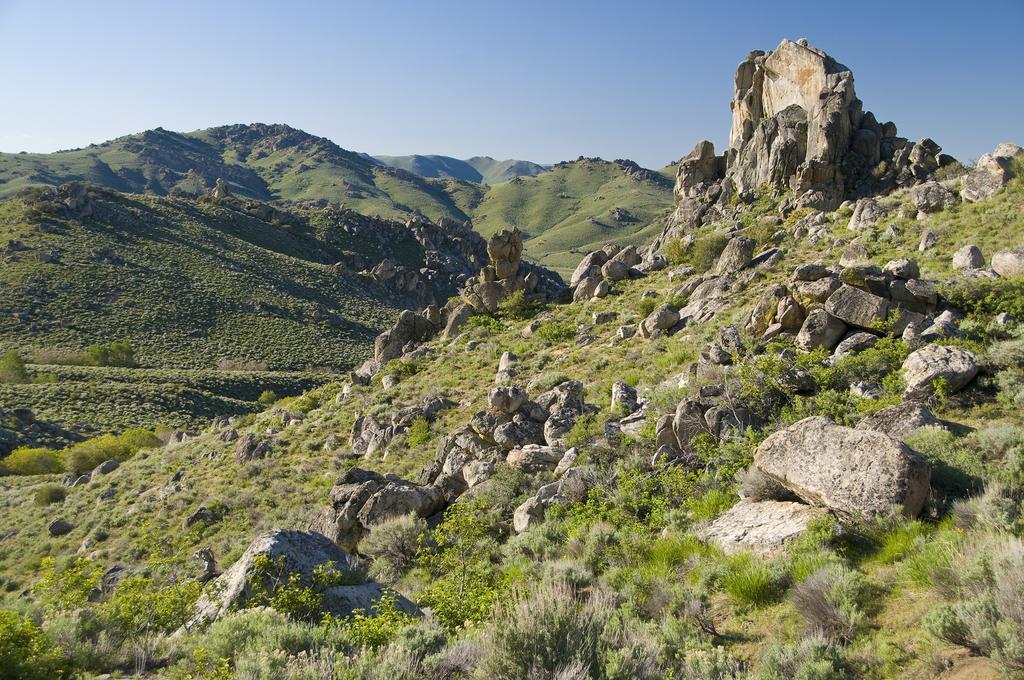Describe this image in one or two sentences. In this picture we can see hills, rocks, plants, grass are present. At the top of the image sky is there. 